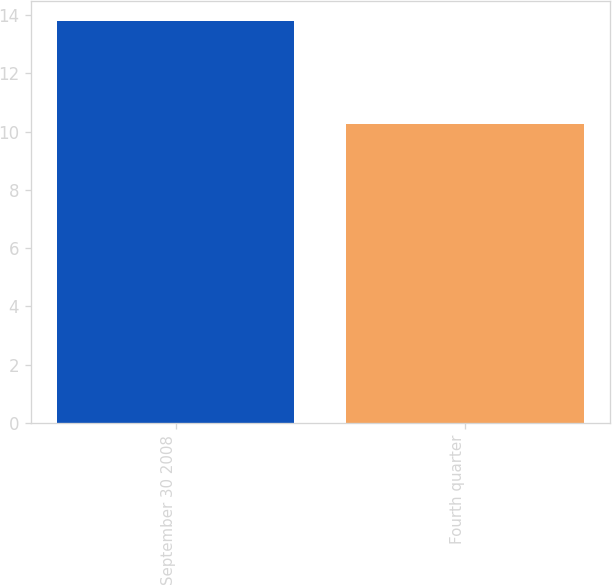<chart> <loc_0><loc_0><loc_500><loc_500><bar_chart><fcel>September 30 2008<fcel>Fourth quarter<nl><fcel>13.81<fcel>10.27<nl></chart> 